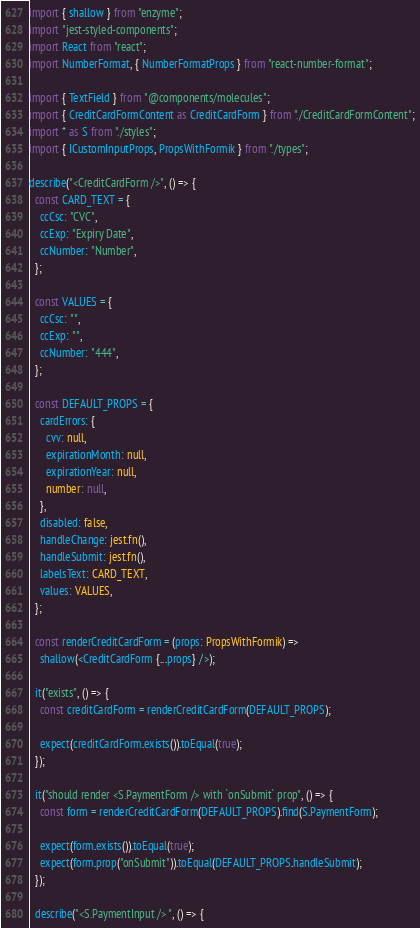Convert code to text. <code><loc_0><loc_0><loc_500><loc_500><_TypeScript_>import { shallow } from "enzyme";
import "jest-styled-components";
import React from "react";
import NumberFormat, { NumberFormatProps } from "react-number-format";

import { TextField } from "@components/molecules";
import { CreditCardFormContent as CreditCardForm } from "./CreditCardFormContent";
import * as S from "./styles";
import { ICustomInputProps, PropsWithFormik } from "./types";

describe("<CreditCardForm />", () => {
  const CARD_TEXT = {
    ccCsc: "CVC",
    ccExp: "Expiry Date",
    ccNumber: "Number",
  };

  const VALUES = {
    ccCsc: "",
    ccExp: "",
    ccNumber: "444",
  };

  const DEFAULT_PROPS = {
    cardErrors: {
      cvv: null,
      expirationMonth: null,
      expirationYear: null,
      number: null,
    },
    disabled: false,
    handleChange: jest.fn(),
    handleSubmit: jest.fn(),
    labelsText: CARD_TEXT,
    values: VALUES,
  };

  const renderCreditCardForm = (props: PropsWithFormik) =>
    shallow(<CreditCardForm {...props} />);

  it("exists", () => {
    const creditCardForm = renderCreditCardForm(DEFAULT_PROPS);

    expect(creditCardForm.exists()).toEqual(true);
  });

  it("should render <S.PaymentForm /> with `onSubmit` prop", () => {
    const form = renderCreditCardForm(DEFAULT_PROPS).find(S.PaymentForm);

    expect(form.exists()).toEqual(true);
    expect(form.prop("onSubmit")).toEqual(DEFAULT_PROPS.handleSubmit);
  });

  describe("<S.PaymentInput /> ", () => {</code> 